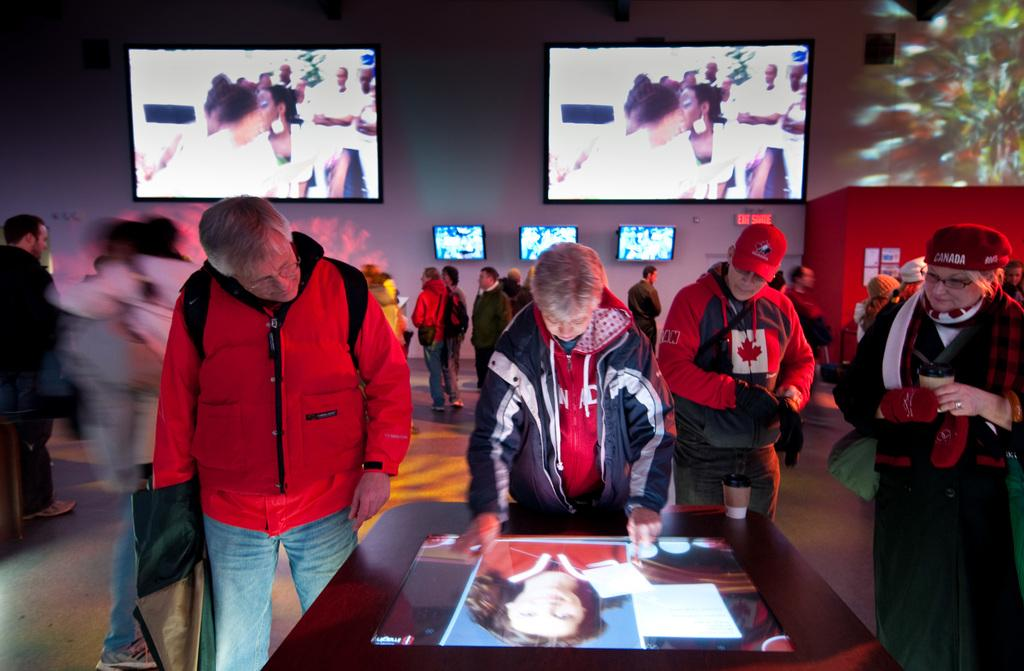What is the position of the televisions in the image? The televisions are mounted on the wall. Can you describe the people in the image? There are people in the image, and four of them are looking at a screen on a table. What is on the red wall in the image? There are boards on the red wall. What is visible in the distance in the image? A signboard is visible in the distance. What advice is the person giving while playing the drum in the image? There is no person playing a drum in the image, and no advice is being given. What type of butter is being used to grease the boards on the red wall in the image? There is no butter present in the image; the boards are simply on the red wall. 